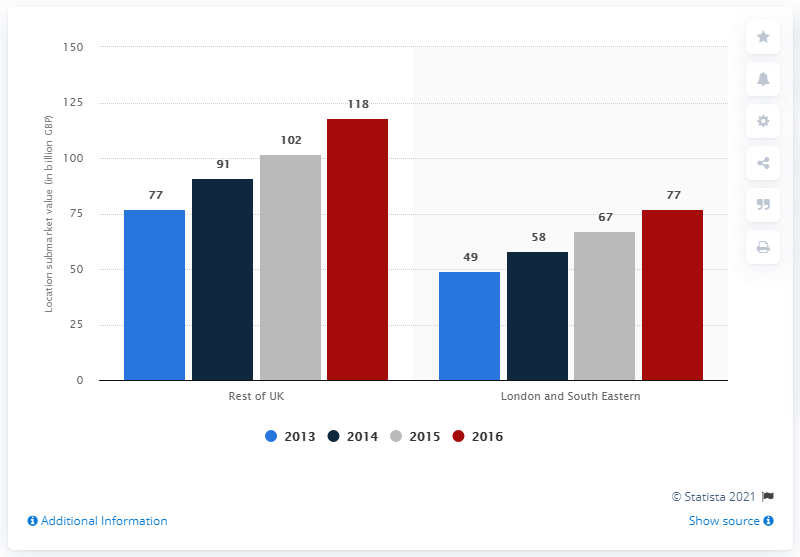Give some essential details in this illustration. The total value of the industrial real estate market in London and the South East from 2013 to 2016 was £77 billion. 